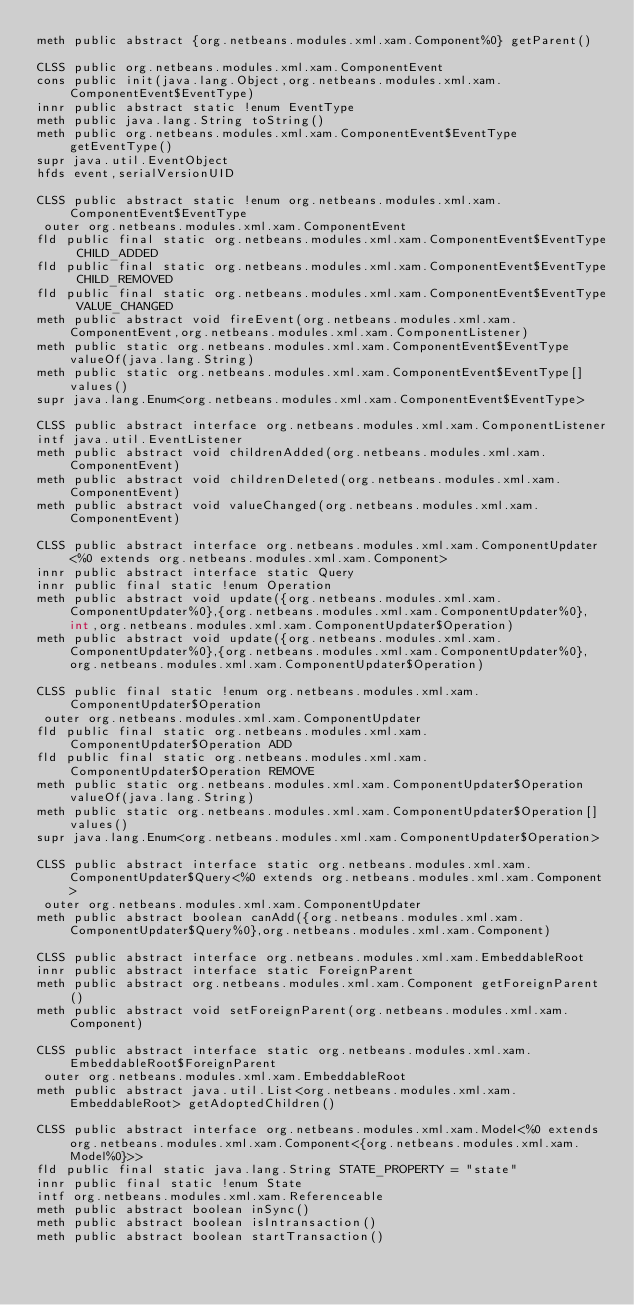Convert code to text. <code><loc_0><loc_0><loc_500><loc_500><_SML_>meth public abstract {org.netbeans.modules.xml.xam.Component%0} getParent()

CLSS public org.netbeans.modules.xml.xam.ComponentEvent
cons public init(java.lang.Object,org.netbeans.modules.xml.xam.ComponentEvent$EventType)
innr public abstract static !enum EventType
meth public java.lang.String toString()
meth public org.netbeans.modules.xml.xam.ComponentEvent$EventType getEventType()
supr java.util.EventObject
hfds event,serialVersionUID

CLSS public abstract static !enum org.netbeans.modules.xml.xam.ComponentEvent$EventType
 outer org.netbeans.modules.xml.xam.ComponentEvent
fld public final static org.netbeans.modules.xml.xam.ComponentEvent$EventType CHILD_ADDED
fld public final static org.netbeans.modules.xml.xam.ComponentEvent$EventType CHILD_REMOVED
fld public final static org.netbeans.modules.xml.xam.ComponentEvent$EventType VALUE_CHANGED
meth public abstract void fireEvent(org.netbeans.modules.xml.xam.ComponentEvent,org.netbeans.modules.xml.xam.ComponentListener)
meth public static org.netbeans.modules.xml.xam.ComponentEvent$EventType valueOf(java.lang.String)
meth public static org.netbeans.modules.xml.xam.ComponentEvent$EventType[] values()
supr java.lang.Enum<org.netbeans.modules.xml.xam.ComponentEvent$EventType>

CLSS public abstract interface org.netbeans.modules.xml.xam.ComponentListener
intf java.util.EventListener
meth public abstract void childrenAdded(org.netbeans.modules.xml.xam.ComponentEvent)
meth public abstract void childrenDeleted(org.netbeans.modules.xml.xam.ComponentEvent)
meth public abstract void valueChanged(org.netbeans.modules.xml.xam.ComponentEvent)

CLSS public abstract interface org.netbeans.modules.xml.xam.ComponentUpdater<%0 extends org.netbeans.modules.xml.xam.Component>
innr public abstract interface static Query
innr public final static !enum Operation
meth public abstract void update({org.netbeans.modules.xml.xam.ComponentUpdater%0},{org.netbeans.modules.xml.xam.ComponentUpdater%0},int,org.netbeans.modules.xml.xam.ComponentUpdater$Operation)
meth public abstract void update({org.netbeans.modules.xml.xam.ComponentUpdater%0},{org.netbeans.modules.xml.xam.ComponentUpdater%0},org.netbeans.modules.xml.xam.ComponentUpdater$Operation)

CLSS public final static !enum org.netbeans.modules.xml.xam.ComponentUpdater$Operation
 outer org.netbeans.modules.xml.xam.ComponentUpdater
fld public final static org.netbeans.modules.xml.xam.ComponentUpdater$Operation ADD
fld public final static org.netbeans.modules.xml.xam.ComponentUpdater$Operation REMOVE
meth public static org.netbeans.modules.xml.xam.ComponentUpdater$Operation valueOf(java.lang.String)
meth public static org.netbeans.modules.xml.xam.ComponentUpdater$Operation[] values()
supr java.lang.Enum<org.netbeans.modules.xml.xam.ComponentUpdater$Operation>

CLSS public abstract interface static org.netbeans.modules.xml.xam.ComponentUpdater$Query<%0 extends org.netbeans.modules.xml.xam.Component>
 outer org.netbeans.modules.xml.xam.ComponentUpdater
meth public abstract boolean canAdd({org.netbeans.modules.xml.xam.ComponentUpdater$Query%0},org.netbeans.modules.xml.xam.Component)

CLSS public abstract interface org.netbeans.modules.xml.xam.EmbeddableRoot
innr public abstract interface static ForeignParent
meth public abstract org.netbeans.modules.xml.xam.Component getForeignParent()
meth public abstract void setForeignParent(org.netbeans.modules.xml.xam.Component)

CLSS public abstract interface static org.netbeans.modules.xml.xam.EmbeddableRoot$ForeignParent
 outer org.netbeans.modules.xml.xam.EmbeddableRoot
meth public abstract java.util.List<org.netbeans.modules.xml.xam.EmbeddableRoot> getAdoptedChildren()

CLSS public abstract interface org.netbeans.modules.xml.xam.Model<%0 extends org.netbeans.modules.xml.xam.Component<{org.netbeans.modules.xml.xam.Model%0}>>
fld public final static java.lang.String STATE_PROPERTY = "state"
innr public final static !enum State
intf org.netbeans.modules.xml.xam.Referenceable
meth public abstract boolean inSync()
meth public abstract boolean isIntransaction()
meth public abstract boolean startTransaction()</code> 